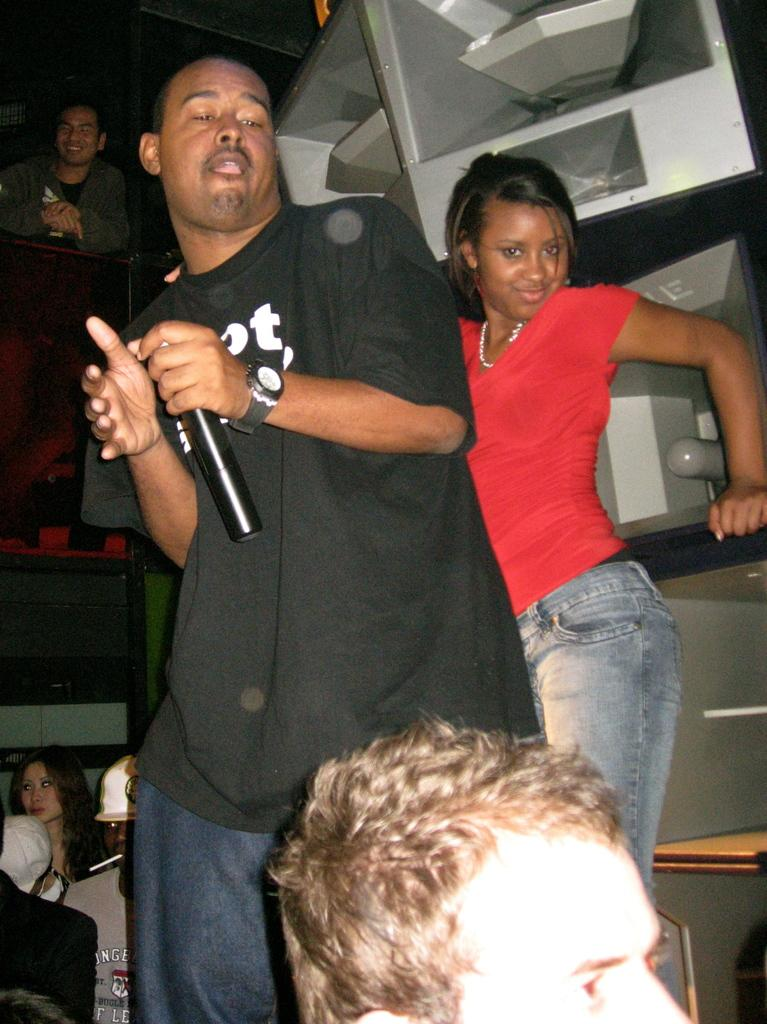How many people are in the image? There are multiple persons in the image. What are the positions of two of the persons in the image? Two of the persons are standing. What object is being held by one of the persons in the image? One person is holding a microphone. What type of knowledge is being shared in the image? There is no indication of knowledge being shared in the image; it only shows multiple persons, two of whom are standing, and one holding a microphone. Is there any quicksand present in the image? There is no quicksand present in the image. 